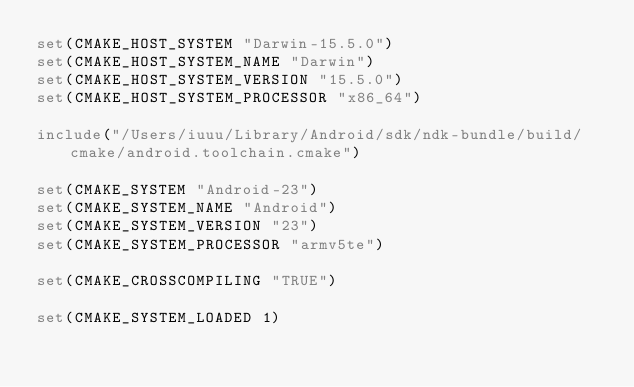<code> <loc_0><loc_0><loc_500><loc_500><_CMake_>set(CMAKE_HOST_SYSTEM "Darwin-15.5.0")
set(CMAKE_HOST_SYSTEM_NAME "Darwin")
set(CMAKE_HOST_SYSTEM_VERSION "15.5.0")
set(CMAKE_HOST_SYSTEM_PROCESSOR "x86_64")

include("/Users/iuuu/Library/Android/sdk/ndk-bundle/build/cmake/android.toolchain.cmake")

set(CMAKE_SYSTEM "Android-23")
set(CMAKE_SYSTEM_NAME "Android")
set(CMAKE_SYSTEM_VERSION "23")
set(CMAKE_SYSTEM_PROCESSOR "armv5te")

set(CMAKE_CROSSCOMPILING "TRUE")

set(CMAKE_SYSTEM_LOADED 1)
</code> 